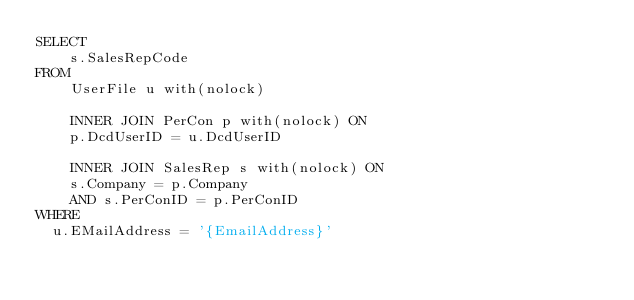Convert code to text. <code><loc_0><loc_0><loc_500><loc_500><_SQL_>SELECT
    s.SalesRepCode
FROM
    UserFile u with(nolock)

    INNER JOIN PerCon p with(nolock) ON
    p.DcdUserID = u.DcdUserID

    INNER JOIN SalesRep s with(nolock) ON
    s.Company = p.Company
    AND s.PerConID = p.PerConID
WHERE
	u.EMailAddress = '{EmailAddress}'</code> 